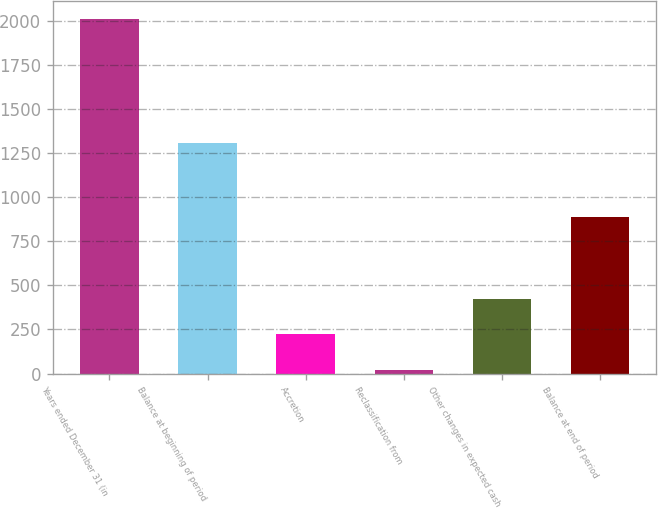<chart> <loc_0><loc_0><loc_500><loc_500><bar_chart><fcel>Years ended December 31 (in<fcel>Balance at beginning of period<fcel>Accretion<fcel>Reclassification from<fcel>Other changes in expected cash<fcel>Balance at end of period<nl><fcel>2012<fcel>1310.4<fcel>221.63<fcel>22.7<fcel>420.56<fcel>890.2<nl></chart> 